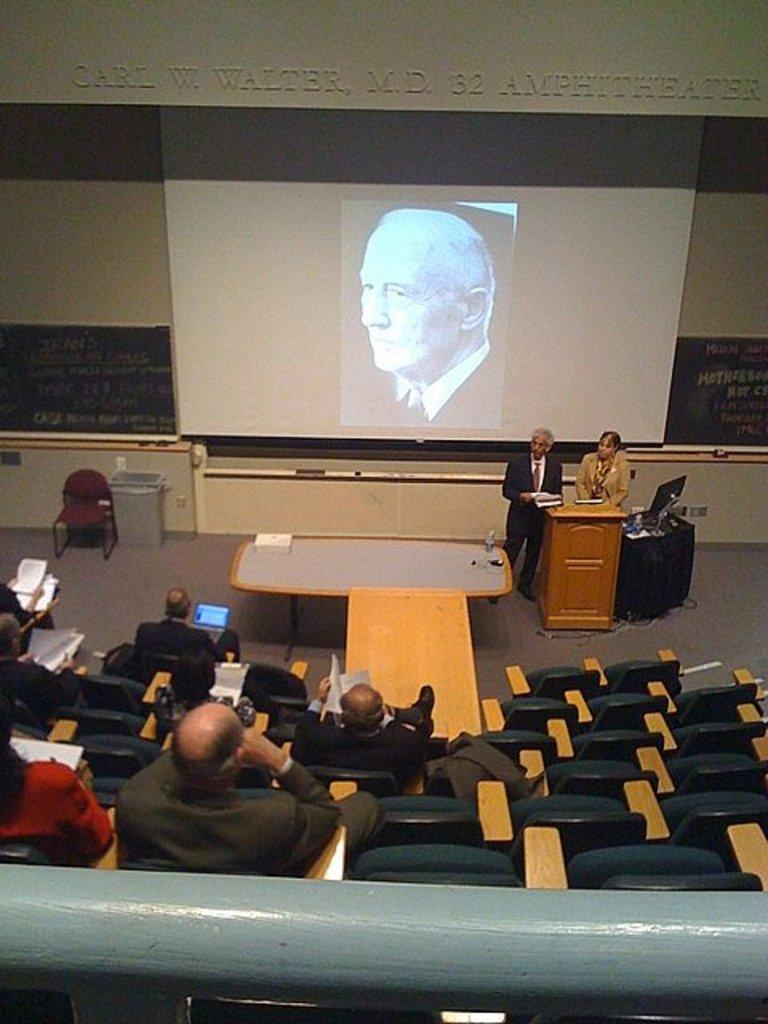How many people are standing in the image? There are two people standing on the floor in the image. What are the other people in the image doing? There is a group of people sitting on chairs in the image. What device can be seen in the image that might be used for presentations? There is a projector in the image. What type of debt is being discussed by the people in the image? There is no indication in the image that the people are discussing debt, as the focus appears to be on the standing and sitting individuals and the projector. 